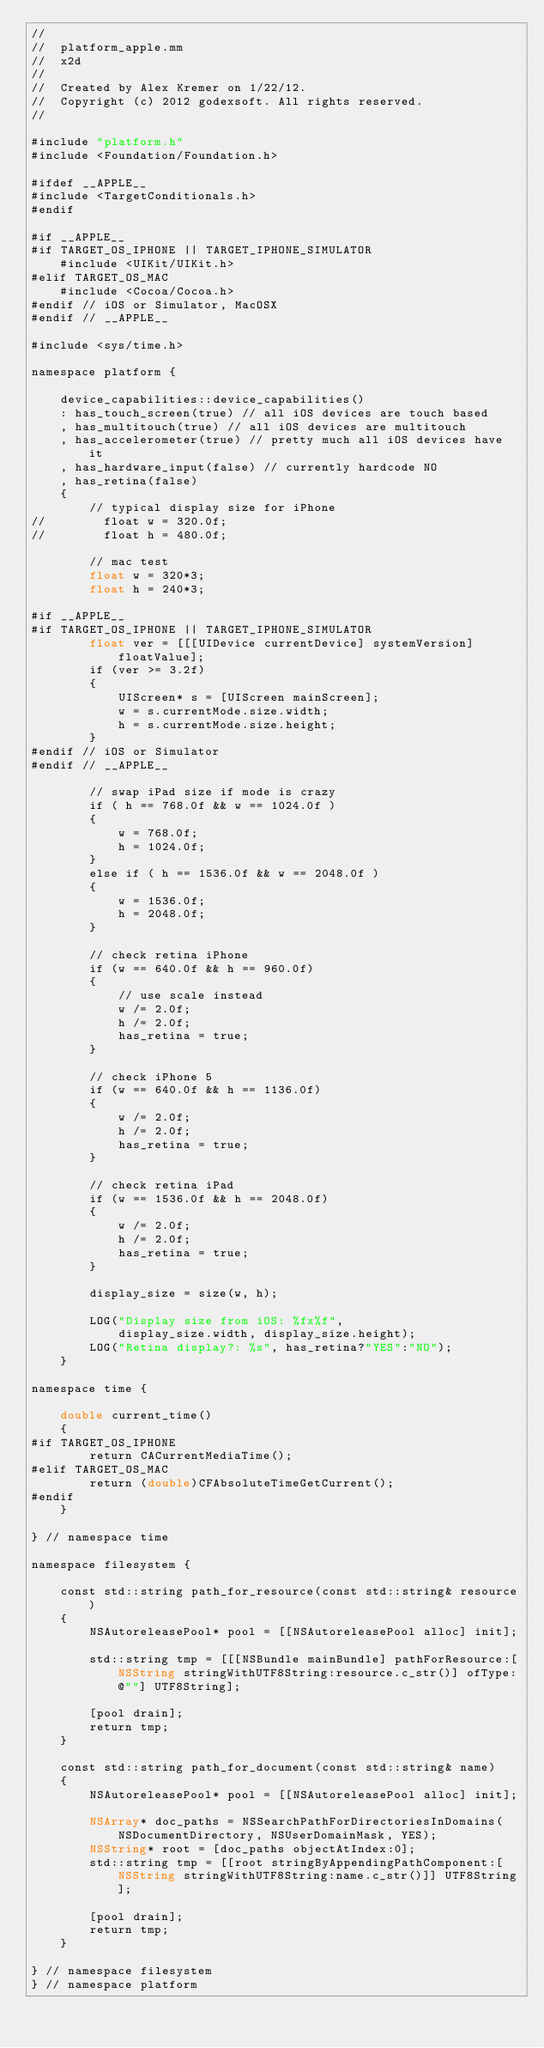Convert code to text. <code><loc_0><loc_0><loc_500><loc_500><_ObjectiveC_>//
//  platform_apple.mm
//  x2d
//
//  Created by Alex Kremer on 1/22/12.
//  Copyright (c) 2012 godexsoft. All rights reserved.
//

#include "platform.h"
#include <Foundation/Foundation.h>

#ifdef __APPLE__
#include <TargetConditionals.h>
#endif

#if __APPLE__
#if TARGET_OS_IPHONE || TARGET_IPHONE_SIMULATOR
    #include <UIKit/UIKit.h>
#elif TARGET_OS_MAC
    #include <Cocoa/Cocoa.h>   
#endif // iOS or Simulator, MacOSX
#endif // __APPLE__

#include <sys/time.h>

namespace platform {
    
    device_capabilities::device_capabilities()
    : has_touch_screen(true) // all iOS devices are touch based
    , has_multitouch(true) // all iOS devices are multitouch
    , has_accelerometer(true) // pretty much all iOS devices have it
    , has_hardware_input(false) // currently hardcode NO
    , has_retina(false)
    {
        // typical display size for iPhone
//        float w = 320.0f;
//        float h = 480.0f;
        
        // mac test
        float w = 320*3;
        float h = 240*3;
        
#if __APPLE__
#if TARGET_OS_IPHONE || TARGET_IPHONE_SIMULATOR
        float ver = [[[UIDevice currentDevice] systemVersion] floatValue];
        if (ver >= 3.2f)
        {
            UIScreen* s = [UIScreen mainScreen];
            w = s.currentMode.size.width;
            h = s.currentMode.size.height;
        }
#endif // iOS or Simulator
#endif // __APPLE__
        
        // swap iPad size if mode is crazy
        if ( h == 768.0f && w == 1024.0f )
        {
            w = 768.0f;
            h = 1024.0f;
        }
        else if ( h == 1536.0f && w == 2048.0f )
        {
            w = 1536.0f;
            h = 2048.0f;
        }
        
        // check retina iPhone
        if (w == 640.0f && h == 960.0f)
        {
            // use scale instead
            w /= 2.0f;
            h /= 2.0f;
            has_retina = true;
        }
        
        // check iPhone 5
        if (w == 640.0f && h == 1136.0f)
        {
            w /= 2.0f;
            h /= 2.0f;
            has_retina = true;
        }
        
        // check retina iPad
        if (w == 1536.0f && h == 2048.0f)
        {
            w /= 2.0f;
            h /= 2.0f;
            has_retina = true;
        }
        
        display_size = size(w, h);
        
        LOG("Display size from iOS: %fx%f",
            display_size.width, display_size.height);
        LOG("Retina display?: %s", has_retina?"YES":"NO");
    }
    
namespace time {
    
    double current_time()
    {
#if TARGET_OS_IPHONE
        return CACurrentMediaTime();
#elif TARGET_OS_MAC
        return (double)CFAbsoluteTimeGetCurrent();
#endif
    }
    
} // namespace time

namespace filesystem {
    
    const std::string path_for_resource(const std::string& resource)
    {
        NSAutoreleasePool* pool = [[NSAutoreleasePool alloc] init];
        
        std::string tmp = [[[NSBundle mainBundle] pathForResource:[NSString stringWithUTF8String:resource.c_str()] ofType:@""] UTF8String];
        
        [pool drain];
        return tmp;
    }
    
    const std::string path_for_document(const std::string& name)
    {
        NSAutoreleasePool* pool = [[NSAutoreleasePool alloc] init];
        
        NSArray* doc_paths = NSSearchPathForDirectoriesInDomains(NSDocumentDirectory, NSUserDomainMask, YES);
        NSString* root = [doc_paths objectAtIndex:0];
        std::string tmp = [[root stringByAppendingPathComponent:[NSString stringWithUTF8String:name.c_str()]] UTF8String];
        
        [pool drain];
        return tmp;
    }

} // namespace filesystem    
} // namespace platform

</code> 